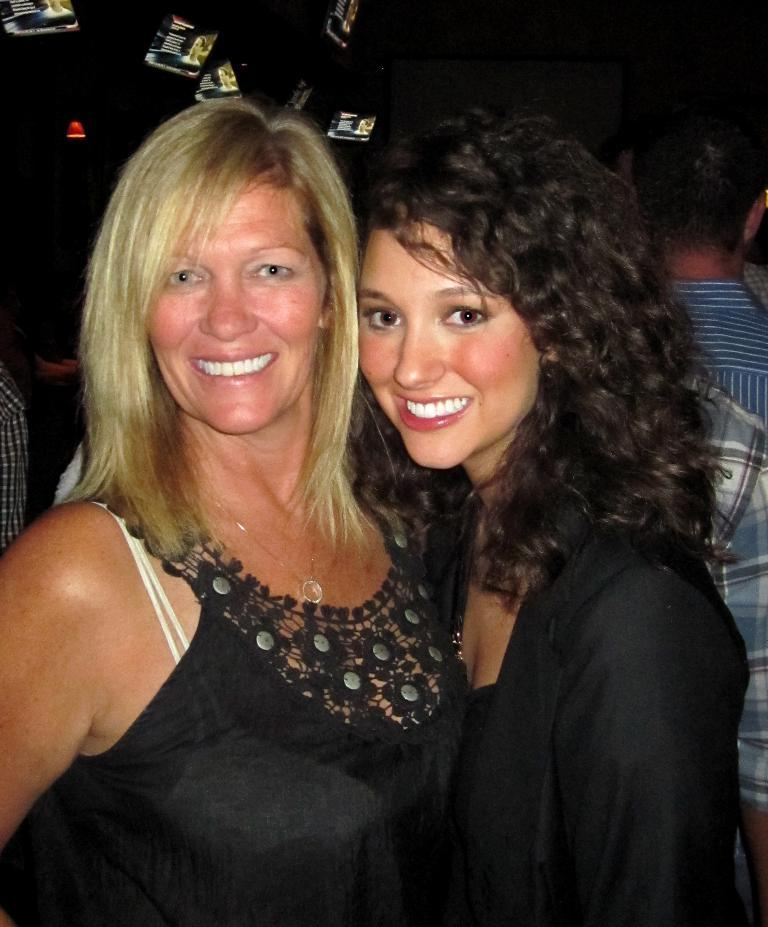What is happening in the image? There are people standing in the image. What can be observed about the lighting in the image? The background of the image is dark. What plot is being discussed by the boy in the library in the image? There is no boy or library present in the image; it only features people standing with a dark background. 